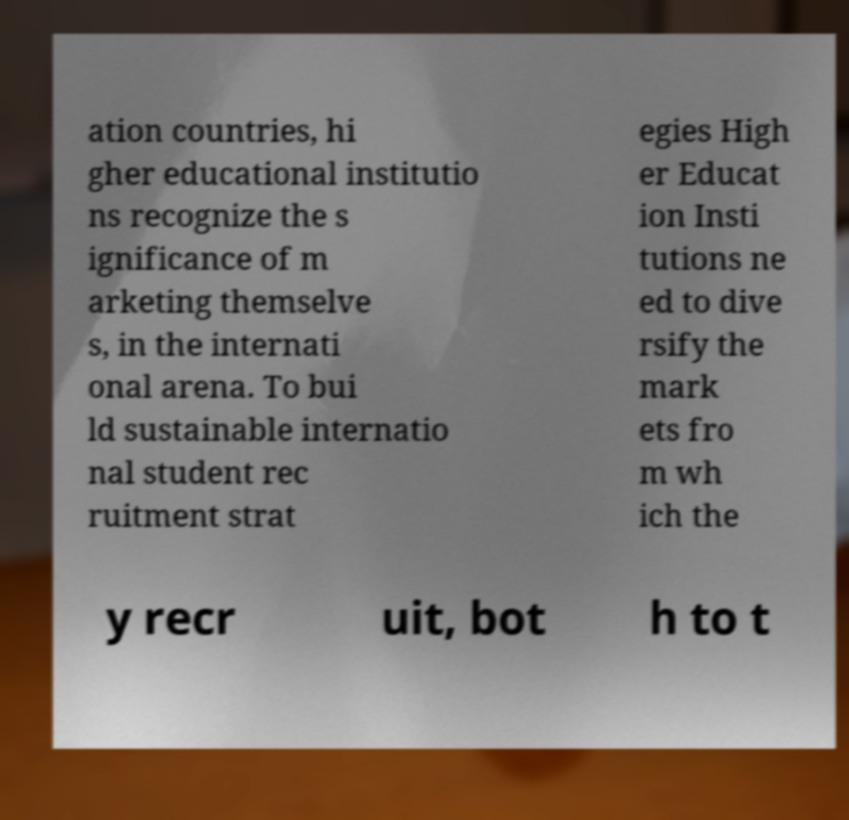Can you accurately transcribe the text from the provided image for me? ation countries, hi gher educational institutio ns recognize the s ignificance of m arketing themselve s, in the internati onal arena. To bui ld sustainable internatio nal student rec ruitment strat egies High er Educat ion Insti tutions ne ed to dive rsify the mark ets fro m wh ich the y recr uit, bot h to t 